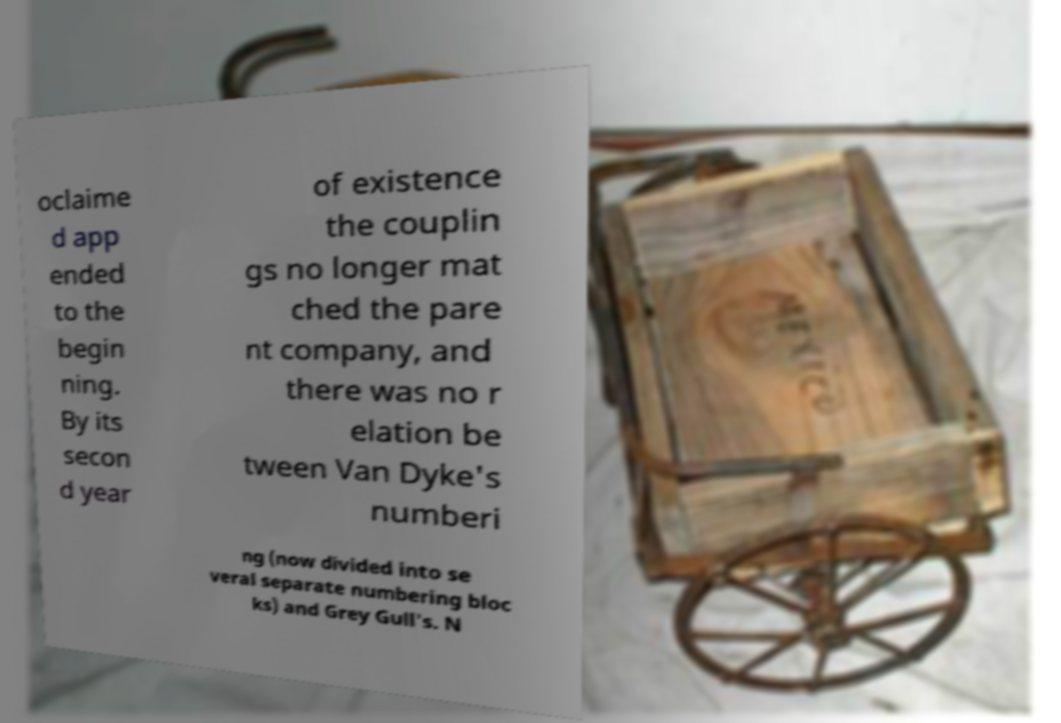Please identify and transcribe the text found in this image. oclaime d app ended to the begin ning. By its secon d year of existence the couplin gs no longer mat ched the pare nt company, and there was no r elation be tween Van Dyke's numberi ng (now divided into se veral separate numbering bloc ks) and Grey Gull's. N 